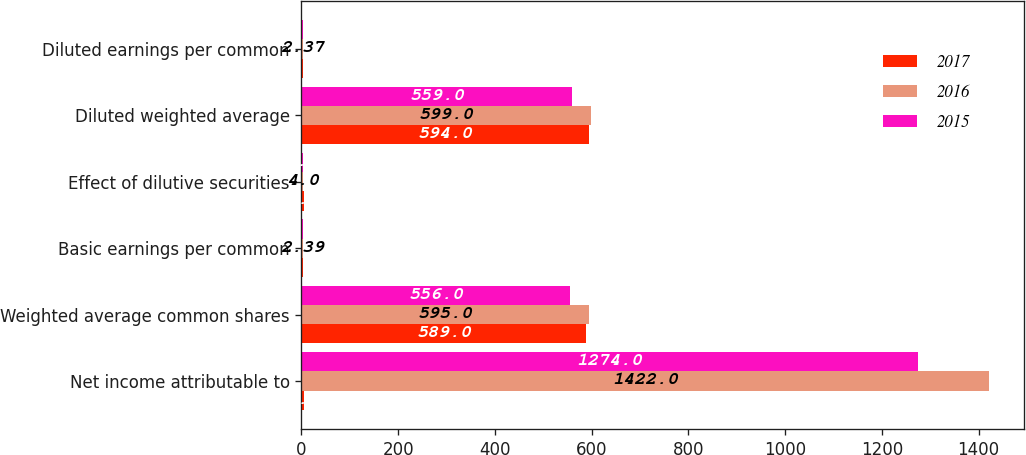Convert chart to OTSL. <chart><loc_0><loc_0><loc_500><loc_500><stacked_bar_chart><ecel><fcel>Net income attributable to<fcel>Weighted average common shares<fcel>Basic earnings per common<fcel>Effect of dilutive securities<fcel>Diluted weighted average<fcel>Diluted earnings per common<nl><fcel>2017<fcel>5<fcel>589<fcel>4.27<fcel>5<fcel>594<fcel>4.23<nl><fcel>2016<fcel>1422<fcel>595<fcel>2.39<fcel>4<fcel>599<fcel>2.37<nl><fcel>2015<fcel>1274<fcel>556<fcel>2.29<fcel>3<fcel>559<fcel>2.28<nl></chart> 